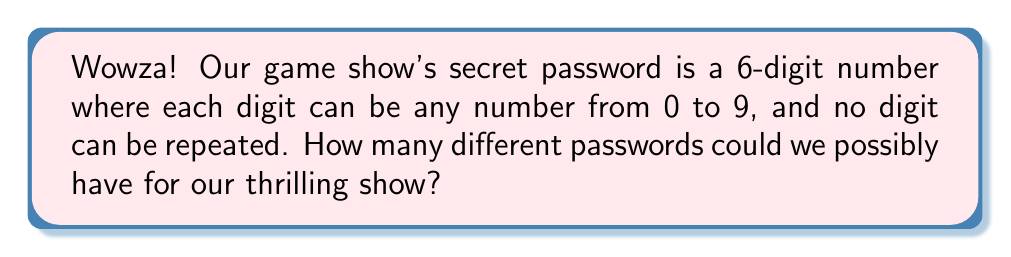Teach me how to tackle this problem. Let's break this down step-by-step, folks!

1) We're dealing with a permutation problem here. We need to choose 6 digits from 10 possible digits (0-9), and the order matters.

2) For the first digit, we have 10 choices (0-9).

3) For the second digit, we can't use the digit we used for the first position, so we have 9 choices.

4) For the third digit, we have 8 choices, and so on.

5) This gives us the following calculation:

   $$10 \times 9 \times 8 \times 7 \times 6 \times 5$$

6) In mathematical notation, this is written as:

   $$P(10,6) = \frac{10!}{(10-6)!} = \frac{10!}{4!}$$

7) Let's calculate this:
   
   $$\frac{10!}{4!} = \frac{10 \times 9 \times 8 \times 7 \times 6 \times 5 \times 4!}{4!}$$
   
   $$= 10 \times 9 \times 8 \times 7 \times 6 \times 5 = 151,200$$

Therefore, there are 151,200 possible passwords for our exciting game show!
Answer: 151,200 